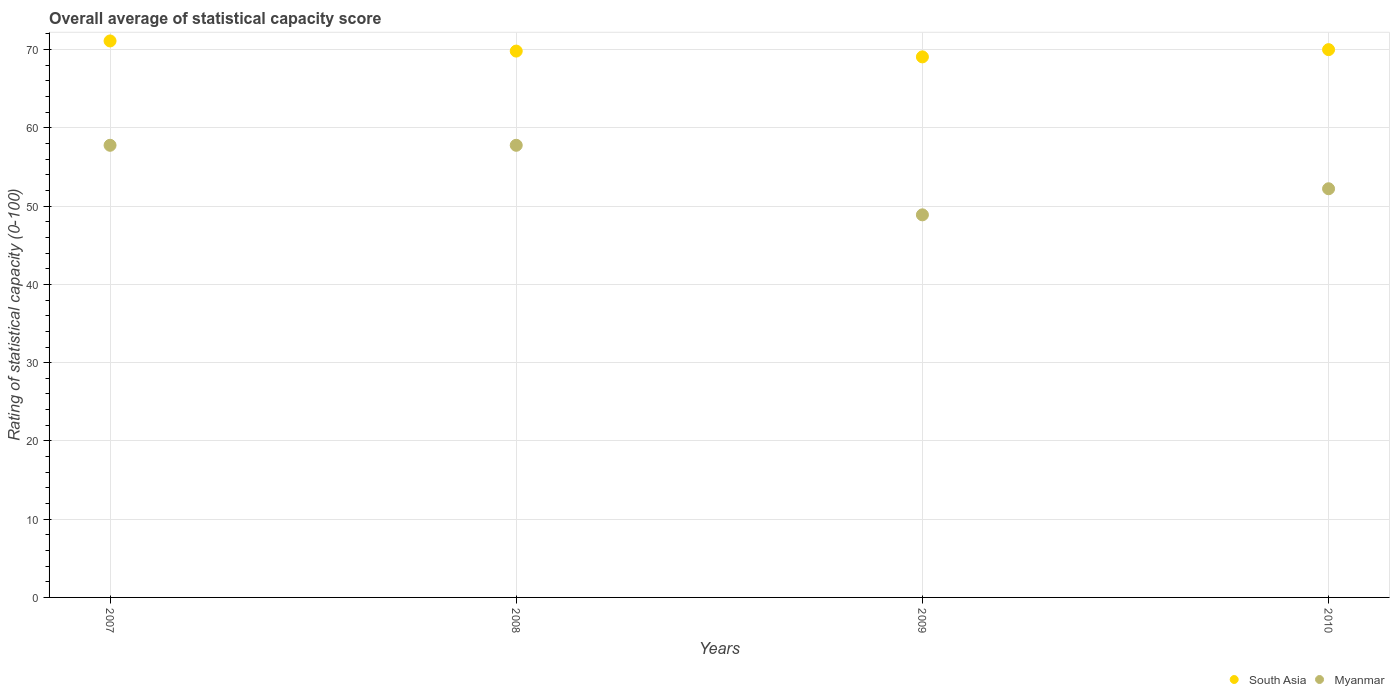How many different coloured dotlines are there?
Your answer should be very brief. 2. What is the rating of statistical capacity in Myanmar in 2009?
Ensure brevity in your answer.  48.89. Across all years, what is the maximum rating of statistical capacity in Myanmar?
Make the answer very short. 57.78. Across all years, what is the minimum rating of statistical capacity in Myanmar?
Your answer should be very brief. 48.89. What is the total rating of statistical capacity in Myanmar in the graph?
Provide a short and direct response. 216.67. What is the difference between the rating of statistical capacity in Myanmar in 2009 and that in 2010?
Your answer should be compact. -3.33. What is the difference between the rating of statistical capacity in Myanmar in 2009 and the rating of statistical capacity in South Asia in 2008?
Your response must be concise. -20.93. What is the average rating of statistical capacity in Myanmar per year?
Your answer should be compact. 54.17. In the year 2008, what is the difference between the rating of statistical capacity in South Asia and rating of statistical capacity in Myanmar?
Your answer should be compact. 12.04. What is the ratio of the rating of statistical capacity in South Asia in 2007 to that in 2008?
Your answer should be very brief. 1.02. Is the rating of statistical capacity in Myanmar in 2007 less than that in 2009?
Offer a very short reply. No. What is the difference between the highest and the second highest rating of statistical capacity in South Asia?
Your response must be concise. 1.11. What is the difference between the highest and the lowest rating of statistical capacity in South Asia?
Offer a terse response. 2.04. Is the rating of statistical capacity in South Asia strictly less than the rating of statistical capacity in Myanmar over the years?
Your response must be concise. No. What is the difference between two consecutive major ticks on the Y-axis?
Provide a succinct answer. 10. Does the graph contain any zero values?
Your answer should be very brief. No. How are the legend labels stacked?
Give a very brief answer. Horizontal. What is the title of the graph?
Provide a short and direct response. Overall average of statistical capacity score. Does "Uzbekistan" appear as one of the legend labels in the graph?
Your answer should be compact. No. What is the label or title of the X-axis?
Make the answer very short. Years. What is the label or title of the Y-axis?
Make the answer very short. Rating of statistical capacity (0-100). What is the Rating of statistical capacity (0-100) of South Asia in 2007?
Offer a terse response. 71.11. What is the Rating of statistical capacity (0-100) of Myanmar in 2007?
Offer a terse response. 57.78. What is the Rating of statistical capacity (0-100) of South Asia in 2008?
Offer a very short reply. 69.81. What is the Rating of statistical capacity (0-100) in Myanmar in 2008?
Keep it short and to the point. 57.78. What is the Rating of statistical capacity (0-100) of South Asia in 2009?
Make the answer very short. 69.07. What is the Rating of statistical capacity (0-100) of Myanmar in 2009?
Make the answer very short. 48.89. What is the Rating of statistical capacity (0-100) of Myanmar in 2010?
Give a very brief answer. 52.22. Across all years, what is the maximum Rating of statistical capacity (0-100) of South Asia?
Your response must be concise. 71.11. Across all years, what is the maximum Rating of statistical capacity (0-100) in Myanmar?
Give a very brief answer. 57.78. Across all years, what is the minimum Rating of statistical capacity (0-100) in South Asia?
Provide a short and direct response. 69.07. Across all years, what is the minimum Rating of statistical capacity (0-100) in Myanmar?
Give a very brief answer. 48.89. What is the total Rating of statistical capacity (0-100) of South Asia in the graph?
Provide a succinct answer. 280. What is the total Rating of statistical capacity (0-100) of Myanmar in the graph?
Provide a succinct answer. 216.67. What is the difference between the Rating of statistical capacity (0-100) of South Asia in 2007 and that in 2008?
Keep it short and to the point. 1.3. What is the difference between the Rating of statistical capacity (0-100) of South Asia in 2007 and that in 2009?
Your answer should be compact. 2.04. What is the difference between the Rating of statistical capacity (0-100) in Myanmar in 2007 and that in 2009?
Your response must be concise. 8.89. What is the difference between the Rating of statistical capacity (0-100) in South Asia in 2007 and that in 2010?
Give a very brief answer. 1.11. What is the difference between the Rating of statistical capacity (0-100) in Myanmar in 2007 and that in 2010?
Offer a terse response. 5.56. What is the difference between the Rating of statistical capacity (0-100) of South Asia in 2008 and that in 2009?
Your answer should be very brief. 0.74. What is the difference between the Rating of statistical capacity (0-100) of Myanmar in 2008 and that in 2009?
Your answer should be very brief. 8.89. What is the difference between the Rating of statistical capacity (0-100) of South Asia in 2008 and that in 2010?
Make the answer very short. -0.19. What is the difference between the Rating of statistical capacity (0-100) of Myanmar in 2008 and that in 2010?
Your response must be concise. 5.56. What is the difference between the Rating of statistical capacity (0-100) of South Asia in 2009 and that in 2010?
Provide a short and direct response. -0.93. What is the difference between the Rating of statistical capacity (0-100) in South Asia in 2007 and the Rating of statistical capacity (0-100) in Myanmar in 2008?
Provide a short and direct response. 13.33. What is the difference between the Rating of statistical capacity (0-100) of South Asia in 2007 and the Rating of statistical capacity (0-100) of Myanmar in 2009?
Provide a short and direct response. 22.22. What is the difference between the Rating of statistical capacity (0-100) of South Asia in 2007 and the Rating of statistical capacity (0-100) of Myanmar in 2010?
Your answer should be very brief. 18.89. What is the difference between the Rating of statistical capacity (0-100) of South Asia in 2008 and the Rating of statistical capacity (0-100) of Myanmar in 2009?
Your answer should be very brief. 20.93. What is the difference between the Rating of statistical capacity (0-100) of South Asia in 2008 and the Rating of statistical capacity (0-100) of Myanmar in 2010?
Make the answer very short. 17.59. What is the difference between the Rating of statistical capacity (0-100) in South Asia in 2009 and the Rating of statistical capacity (0-100) in Myanmar in 2010?
Offer a terse response. 16.85. What is the average Rating of statistical capacity (0-100) of Myanmar per year?
Provide a succinct answer. 54.17. In the year 2007, what is the difference between the Rating of statistical capacity (0-100) of South Asia and Rating of statistical capacity (0-100) of Myanmar?
Your response must be concise. 13.33. In the year 2008, what is the difference between the Rating of statistical capacity (0-100) of South Asia and Rating of statistical capacity (0-100) of Myanmar?
Provide a short and direct response. 12.04. In the year 2009, what is the difference between the Rating of statistical capacity (0-100) in South Asia and Rating of statistical capacity (0-100) in Myanmar?
Make the answer very short. 20.19. In the year 2010, what is the difference between the Rating of statistical capacity (0-100) in South Asia and Rating of statistical capacity (0-100) in Myanmar?
Your response must be concise. 17.78. What is the ratio of the Rating of statistical capacity (0-100) of South Asia in 2007 to that in 2008?
Offer a terse response. 1.02. What is the ratio of the Rating of statistical capacity (0-100) of Myanmar in 2007 to that in 2008?
Ensure brevity in your answer.  1. What is the ratio of the Rating of statistical capacity (0-100) of South Asia in 2007 to that in 2009?
Offer a terse response. 1.03. What is the ratio of the Rating of statistical capacity (0-100) in Myanmar in 2007 to that in 2009?
Ensure brevity in your answer.  1.18. What is the ratio of the Rating of statistical capacity (0-100) in South Asia in 2007 to that in 2010?
Your answer should be very brief. 1.02. What is the ratio of the Rating of statistical capacity (0-100) of Myanmar in 2007 to that in 2010?
Your answer should be very brief. 1.11. What is the ratio of the Rating of statistical capacity (0-100) of South Asia in 2008 to that in 2009?
Make the answer very short. 1.01. What is the ratio of the Rating of statistical capacity (0-100) of Myanmar in 2008 to that in 2009?
Ensure brevity in your answer.  1.18. What is the ratio of the Rating of statistical capacity (0-100) of South Asia in 2008 to that in 2010?
Give a very brief answer. 1. What is the ratio of the Rating of statistical capacity (0-100) of Myanmar in 2008 to that in 2010?
Your answer should be very brief. 1.11. What is the ratio of the Rating of statistical capacity (0-100) in Myanmar in 2009 to that in 2010?
Your answer should be compact. 0.94. What is the difference between the highest and the second highest Rating of statistical capacity (0-100) of Myanmar?
Your response must be concise. 0. What is the difference between the highest and the lowest Rating of statistical capacity (0-100) of South Asia?
Your answer should be very brief. 2.04. What is the difference between the highest and the lowest Rating of statistical capacity (0-100) of Myanmar?
Your response must be concise. 8.89. 